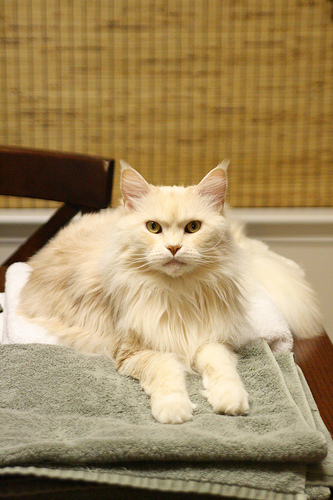<image>
Is the cat on the towel? Yes. Looking at the image, I can see the cat is positioned on top of the towel, with the towel providing support. 